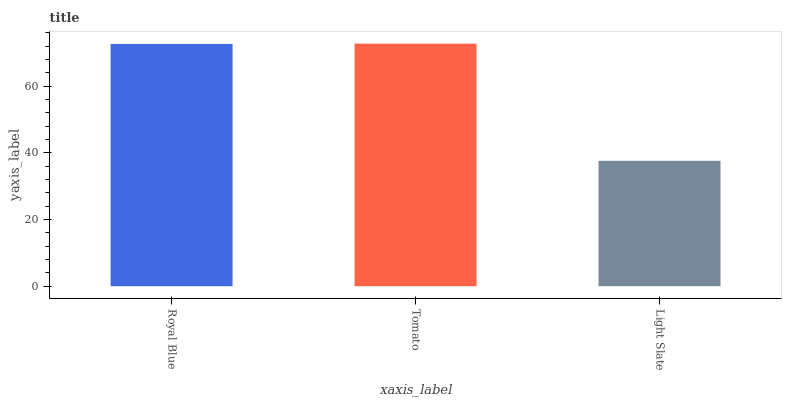Is Light Slate the minimum?
Answer yes or no. Yes. Is Tomato the maximum?
Answer yes or no. Yes. Is Tomato the minimum?
Answer yes or no. No. Is Light Slate the maximum?
Answer yes or no. No. Is Tomato greater than Light Slate?
Answer yes or no. Yes. Is Light Slate less than Tomato?
Answer yes or no. Yes. Is Light Slate greater than Tomato?
Answer yes or no. No. Is Tomato less than Light Slate?
Answer yes or no. No. Is Royal Blue the high median?
Answer yes or no. Yes. Is Royal Blue the low median?
Answer yes or no. Yes. Is Tomato the high median?
Answer yes or no. No. Is Tomato the low median?
Answer yes or no. No. 